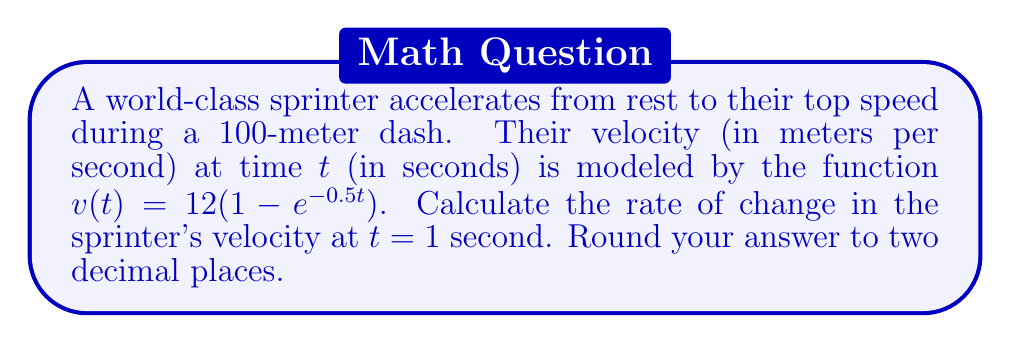Teach me how to tackle this problem. To find the rate of change in the sprinter's velocity, we need to calculate the derivative of the velocity function $v(t)$ and evaluate it at $t = 1$ second.

Step 1: Begin with the velocity function
$$v(t) = 12(1 - e^{-0.5t})$$

Step 2: Calculate the derivative using the chain rule
$$\frac{dv}{dt} = 12 \cdot \frac{d}{dt}(1 - e^{-0.5t})$$
$$\frac{dv}{dt} = 12 \cdot (-1) \cdot (-0.5e^{-0.5t})$$
$$\frac{dv}{dt} = 6e^{-0.5t}$$

Step 3: Evaluate the derivative at $t = 1$
$$\frac{dv}{dt}\bigg|_{t=1} = 6e^{-0.5(1)}$$
$$\frac{dv}{dt}\bigg|_{t=1} = 6e^{-0.5}$$

Step 4: Calculate the numerical value and round to two decimal places
$$\frac{dv}{dt}\bigg|_{t=1} \approx 3.65 \text{ m/s}^2$$
Answer: $3.65 \text{ m/s}^2$ 